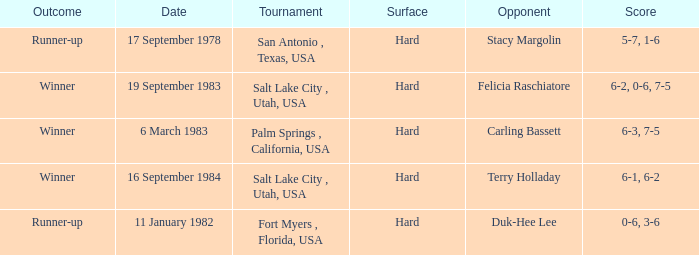What was the conclusion of the match with stacy margolin? Runner-up. 